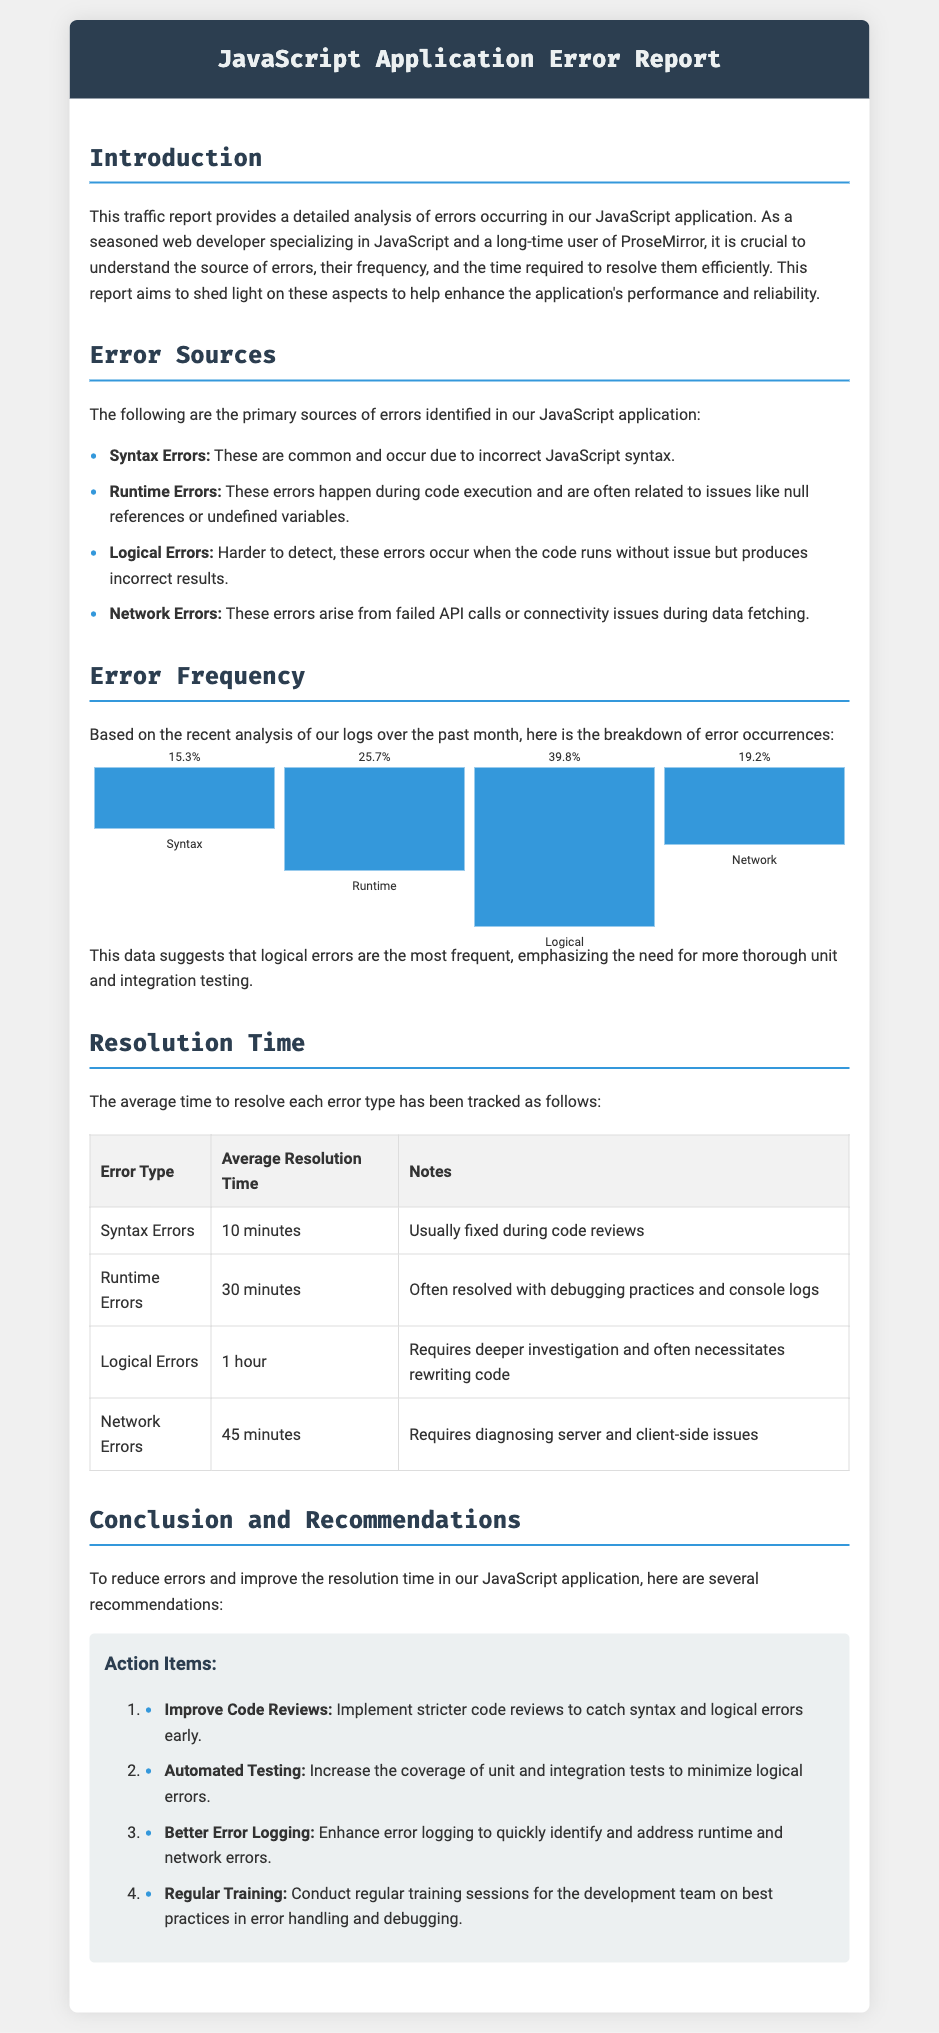What are the primary sources of errors identified? The document lists four different sources of errors in the application, which can be found in the section titled "Error Sources."
Answer: Syntax Errors, Runtime Errors, Logical Errors, Network Errors What percentage of errors are logical errors? The error frequency data includes specific percentages for each error type, with logical errors having the highest percentage.
Answer: 39.8% What is the average resolution time for network errors? The table in the "Resolution Time" section outlines the average time needed to resolve different error types, specifically noting the time for network errors.
Answer: 45 minutes Which error type takes the longest to resolve? By examining the "Resolution Time" table, one can identify the error type with the highest average resolution time.
Answer: Logical Errors What recommendation is made to handle logical errors? The recommendations in the "Conclusion and Recommendations" section highlight specific actions aimed at reducing logical errors.
Answer: Increase the coverage of unit and integration tests Why is debugging important for runtime errors? Explanations are provided in the "Resolution Time" section to describe how different error types are addressed, particularly runtime errors.
Answer: Often resolved with debugging practices and console logs What does the report aim to enhance? The introduction specifies the overall goal of the report, which relates to the application's functionality and reliability.
Answer: Application’s performance and reliability How many error types are tracked for resolution time? The "Resolution Time" table mentions distinct categories of error types being monitored for resolution times.
Answer: Four 